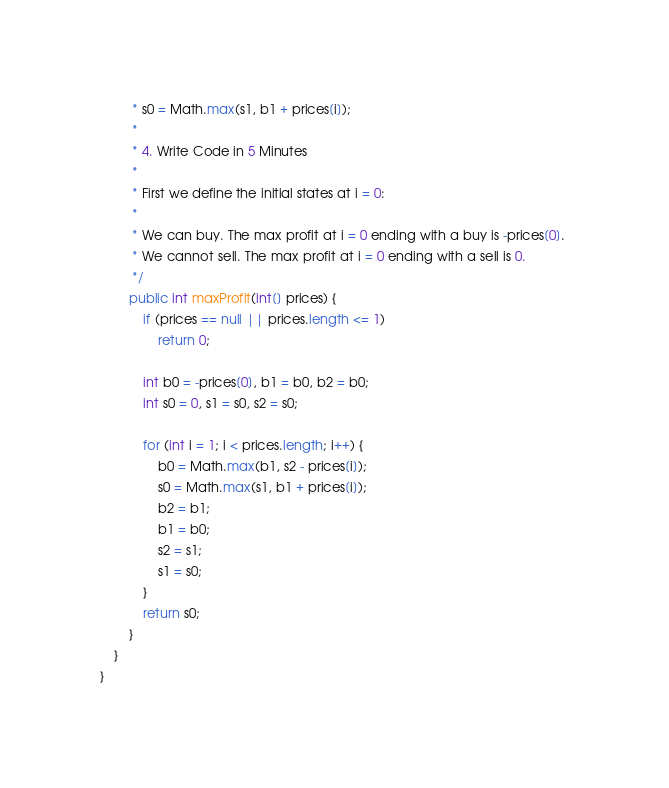<code> <loc_0><loc_0><loc_500><loc_500><_Java_>         * s0 = Math.max(s1, b1 + prices[i]); 
         * 
         * 4. Write Code in 5 Minutes
         * 
         * First we define the initial states at i = 0:
         * 
         * We can buy. The max profit at i = 0 ending with a buy is -prices[0]. 
         * We cannot sell. The max profit at i = 0 ending with a sell is 0.
         */
        public int maxProfit(int[] prices) {
            if (prices == null || prices.length <= 1)
                return 0;

            int b0 = -prices[0], b1 = b0, b2 = b0;
            int s0 = 0, s1 = s0, s2 = s0;

            for (int i = 1; i < prices.length; i++) {
                b0 = Math.max(b1, s2 - prices[i]);
                s0 = Math.max(s1, b1 + prices[i]);
                b2 = b1;
                b1 = b0;
                s2 = s1;
                s1 = s0;
            }
            return s0;
        }
    }
}
</code> 